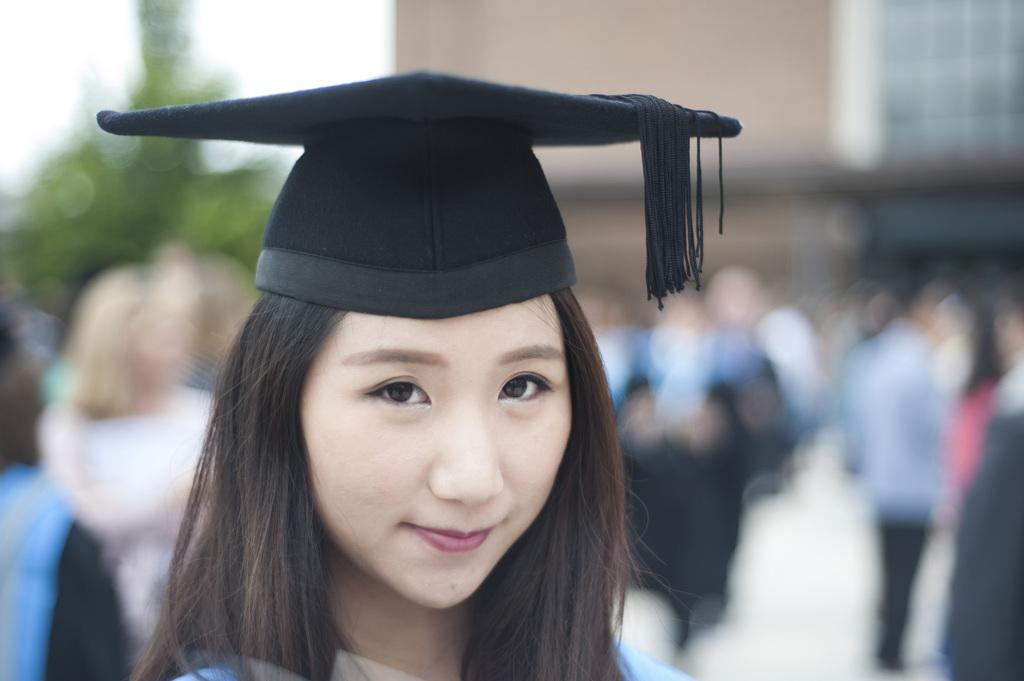What is the main subject of the image? The main subject of the image is a woman. What is the woman wearing on her head? The woman is wearing a cap. What expression does the woman have in the image? The woman is smiling. What type of string is the woman holding in the image? There is no string present in the image. What kind of sheet is visible in the background of the image? There is no sheet visible in the image. 